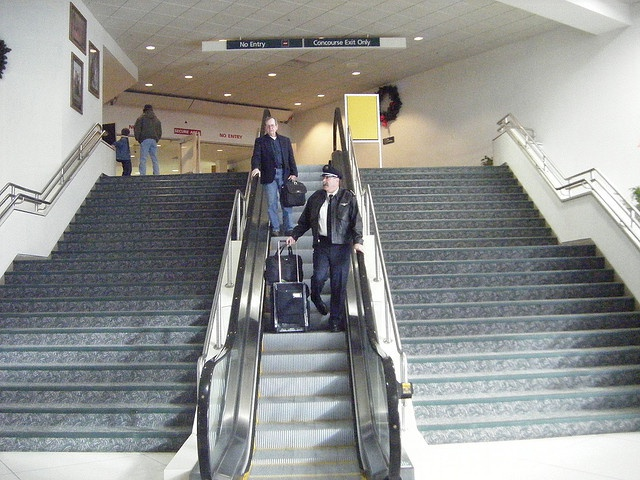Describe the objects in this image and their specific colors. I can see people in darkgray, black, and gray tones, people in darkgray, black, navy, and gray tones, suitcase in darkgray, black, and gray tones, people in darkgray, black, and gray tones, and handbag in darkgray, black, and gray tones in this image. 